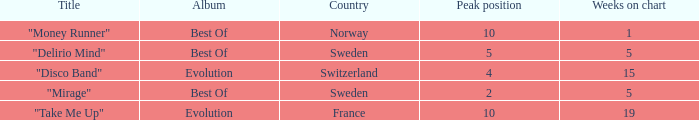What is the country with the album best of and weeks on chart is less than 5? Norway. 